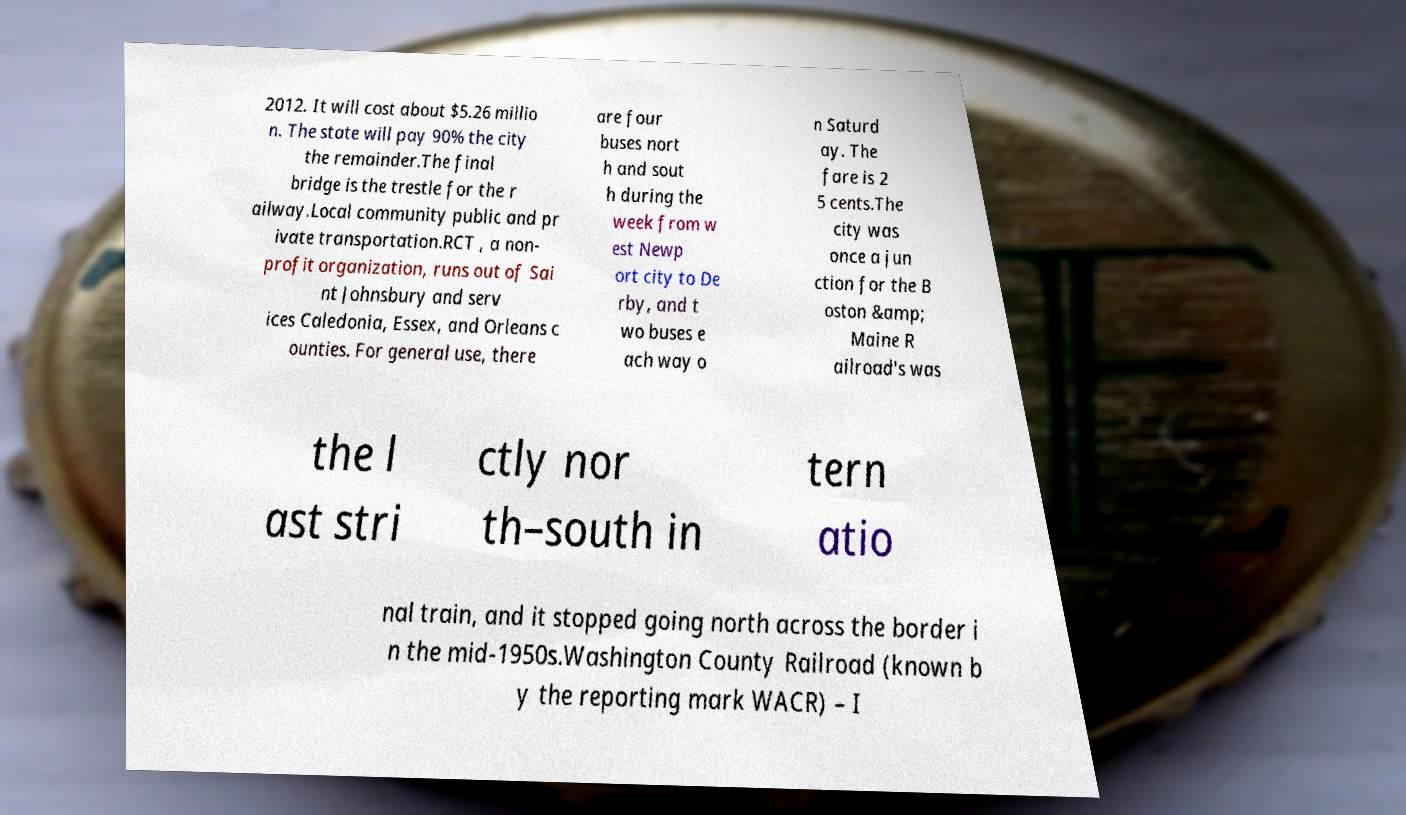I need the written content from this picture converted into text. Can you do that? 2012. It will cost about $5.26 millio n. The state will pay 90% the city the remainder.The final bridge is the trestle for the r ailway.Local community public and pr ivate transportation.RCT , a non- profit organization, runs out of Sai nt Johnsbury and serv ices Caledonia, Essex, and Orleans c ounties. For general use, there are four buses nort h and sout h during the week from w est Newp ort city to De rby, and t wo buses e ach way o n Saturd ay. The fare is 2 5 cents.The city was once a jun ction for the B oston &amp; Maine R ailroad's was the l ast stri ctly nor th–south in tern atio nal train, and it stopped going north across the border i n the mid-1950s.Washington County Railroad (known b y the reporting mark WACR) – I 